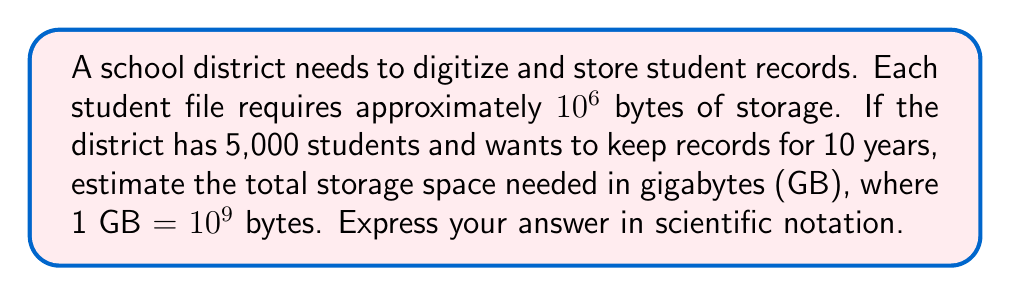Provide a solution to this math problem. Let's break this down step-by-step:

1. Calculate the storage space for one student for one year:
   $10^6$ bytes

2. Calculate the storage space for all students for one year:
   $5,000 \times 10^6 = 5 \times 10^3 \times 10^6 = 5 \times 10^9$ bytes

3. Calculate the storage space for all students for 10 years:
   $5 \times 10^9 \times 10 = 5 \times 10^{10}$ bytes

4. Convert bytes to gigabytes:
   $\frac{5 \times 10^{10}}{10^9} = 5 \times 10^1$ GB

Therefore, the estimated storage space needed is $5 \times 10^1$ GB or 50 GB.
Answer: $5 \times 10^1$ GB 